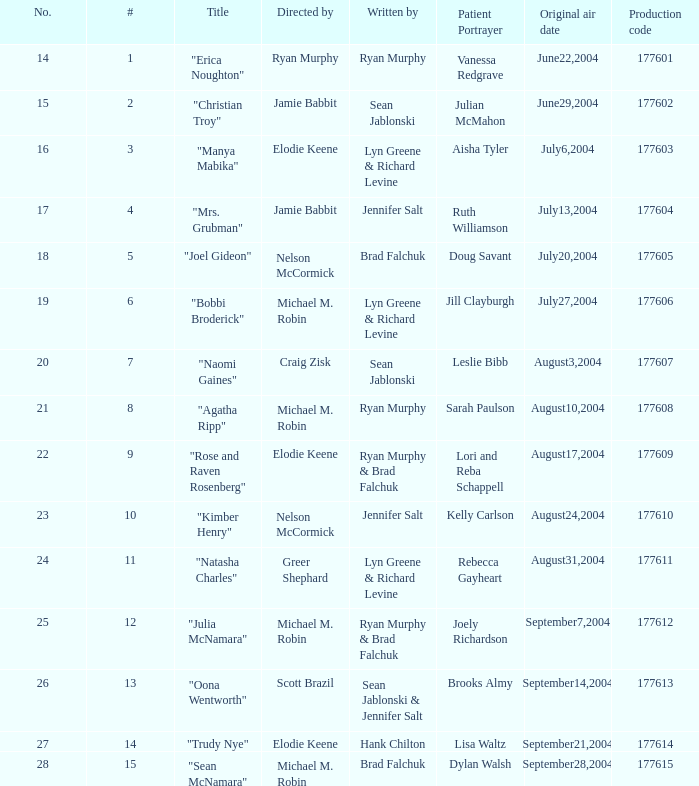What numbered episode is titled "naomi gaines"? 20.0. 